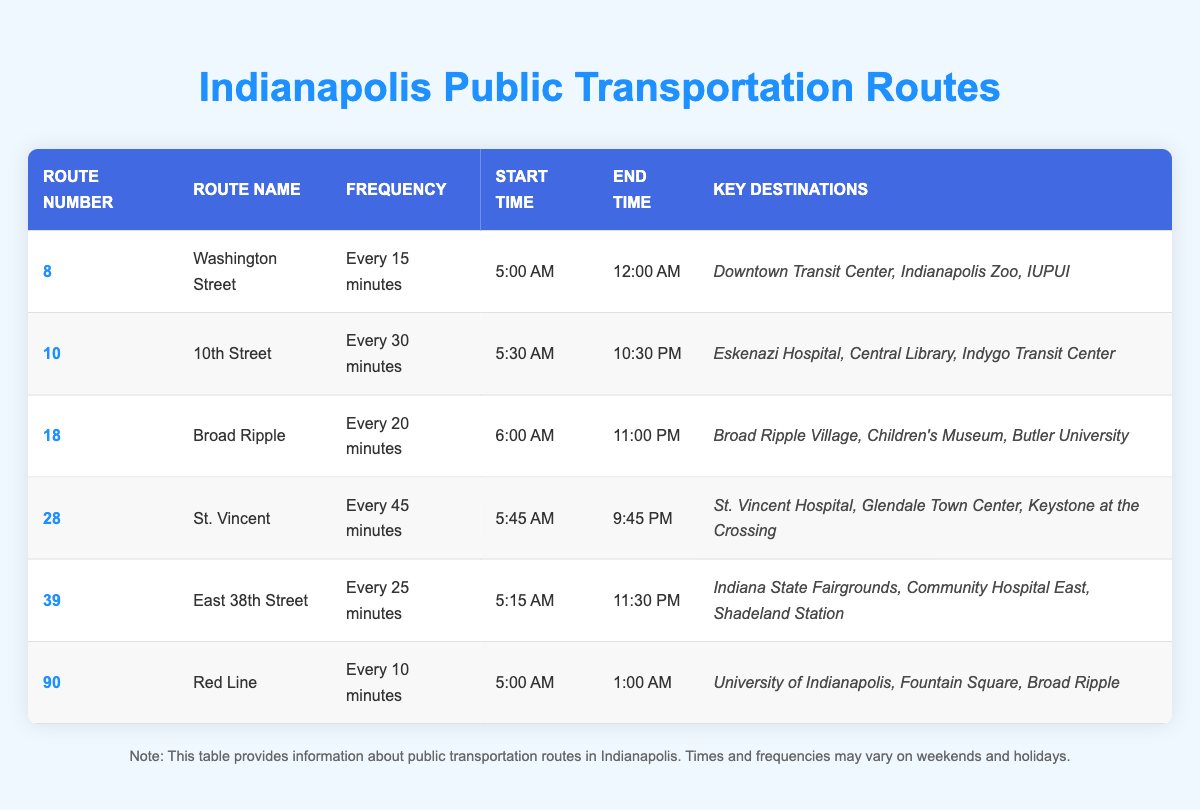What is the frequency of the Red Line? The Red Line appears in the table under the "Frequency" column, and it states it operates "Every 10 minutes."
Answer: Every 10 minutes Which route operates until 12:00 AM? The table includes the "End Time" column, and by checking the entries, the Washington Street route is the only one that runs until 12:00 AM.
Answer: Washington Street What is the frequency of route number 10? Looking at the row for route number 10, the frequency is listed as "Every 30 minutes" in the corresponding column.
Answer: Every 30 minutes Is there a route that runs every 15 minutes? By reviewing the "Frequency" column in the table, it is clear that the Washington Street route runs every 15 minutes.
Answer: Yes How many routes have a frequency of 20 minutes or less? Examining the table, the routes with 20 minutes or less are: Red Line (10 min), Washington Street (15 min), and Broad Ripple (20 min). This totals to three routes.
Answer: 3 Which route has the earliest start time? The start times in the table indicate that route number 8 (Washington Street) starts at 5:00 AM, which is the earliest of all listed routes.
Answer: 5:00 AM What is the latest end time among the routes? The "End Time" column shows that the Red Line finishes at 1:00 AM. This is the latest compared to the other routes.
Answer: 1:00 AM What is the average frequency for all routes listed? Calculating the frequency in minutes: 15 (Red Line) + 30 (10th Street) + 20 (Broad Ripple) + 45 (St. Vincent) + 25 (East 38th) + 10 (Red Line) = 145 minutes. Dividing this by 6 routes gives an average of about 24.17 minutes.
Answer: 24.17 minutes List the key destinations for route number 28. Checking the "Key Destinations" column for route number 28 reveals it lists St. Vincent Hospital, Glendale Town Center, and Keystone at the Crossing.
Answer: St. Vincent Hospital, Glendale Town Center, Keystone at the Crossing 